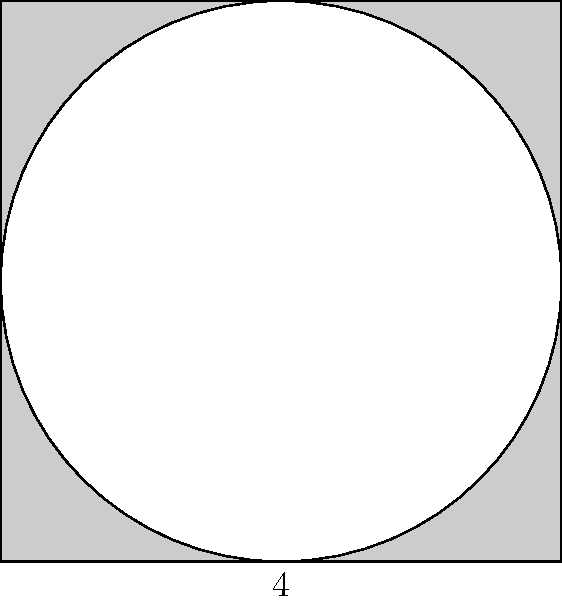As a minimalist icon designer, you're creating a logo composed of a square with a side length of 4 units and a circular cutout centered within it. The circle's diameter is equal to the square's side length. Calculate the area of the resulting shape (the square minus the circular cutout). Round your answer to two decimal places. To solve this problem, we'll follow these steps:

1. Calculate the area of the square:
   $A_{square} = s^2 = 4^2 = 16$ square units

2. Calculate the area of the circle:
   $A_{circle} = \pi r^2 = \pi (2^2) = 4\pi$ square units

3. Subtract the area of the circle from the area of the square:
   $A_{final} = A_{square} - A_{circle} = 16 - 4\pi$

4. Evaluate and round to two decimal places:
   $A_{final} = 16 - 4\pi \approx 16 - 12.57 = 3.43$ square units

This approach demonstrates how simple geometric shapes can be combined to create more complex forms, a principle often used in minimalist design.
Answer: $3.43$ square units 